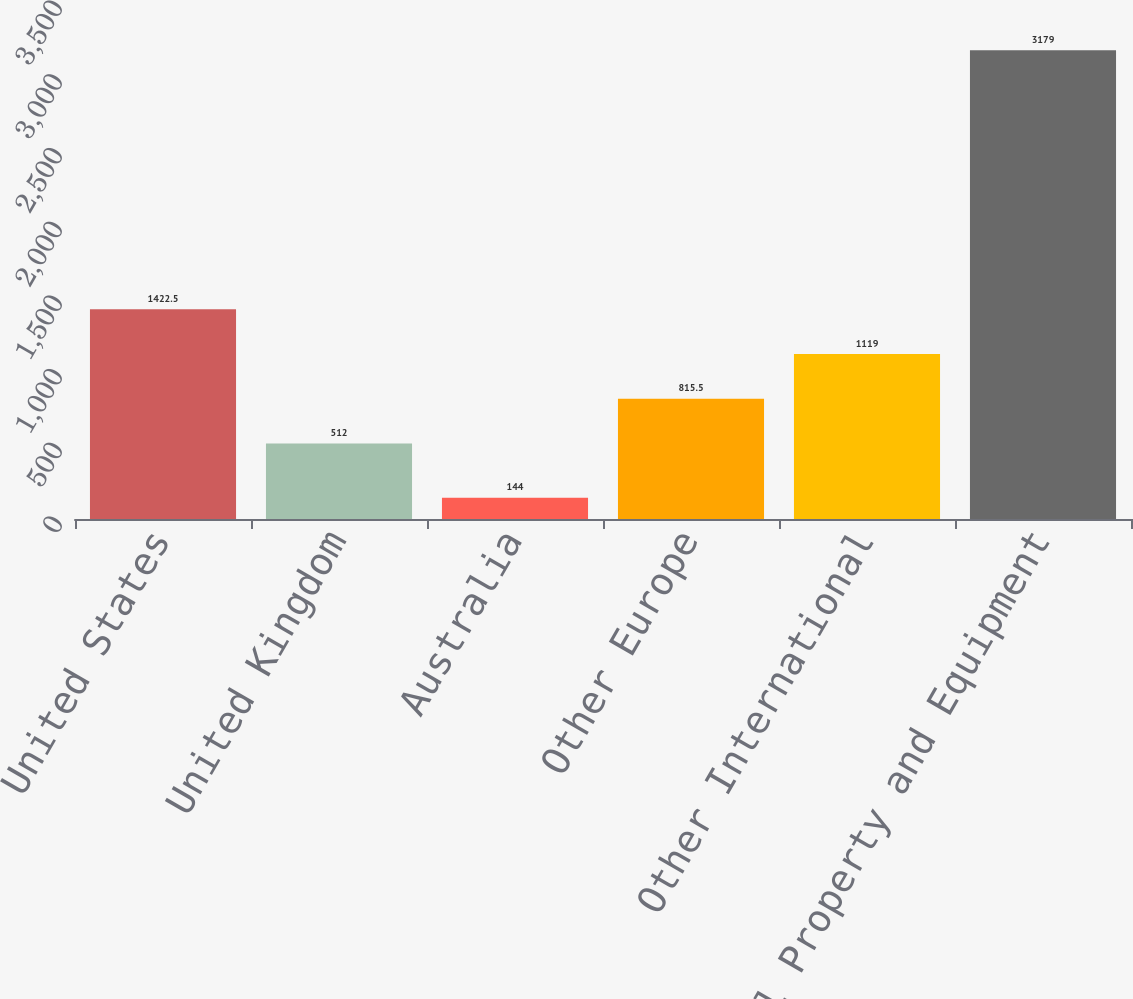Convert chart to OTSL. <chart><loc_0><loc_0><loc_500><loc_500><bar_chart><fcel>United States<fcel>United Kingdom<fcel>Australia<fcel>Other Europe<fcel>Other International<fcel>Total Property and Equipment<nl><fcel>1422.5<fcel>512<fcel>144<fcel>815.5<fcel>1119<fcel>3179<nl></chart> 